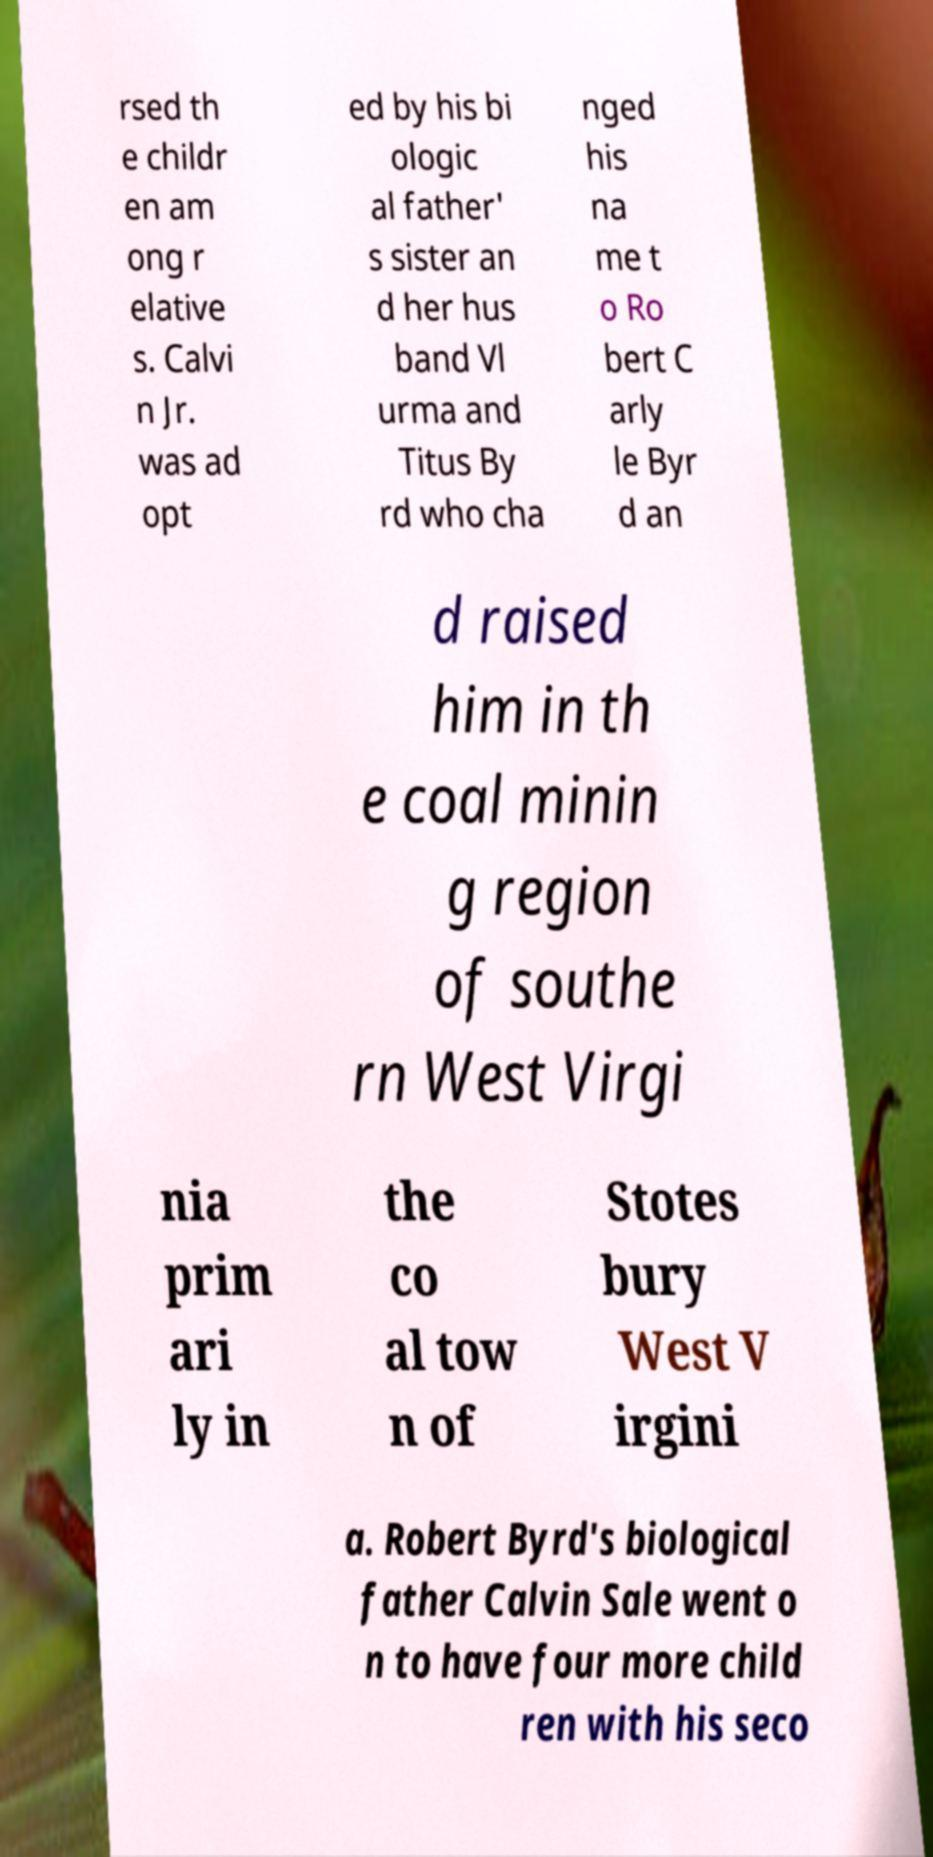What messages or text are displayed in this image? I need them in a readable, typed format. rsed th e childr en am ong r elative s. Calvi n Jr. was ad opt ed by his bi ologic al father' s sister an d her hus band Vl urma and Titus By rd who cha nged his na me t o Ro bert C arly le Byr d an d raised him in th e coal minin g region of southe rn West Virgi nia prim ari ly in the co al tow n of Stotes bury West V irgini a. Robert Byrd's biological father Calvin Sale went o n to have four more child ren with his seco 